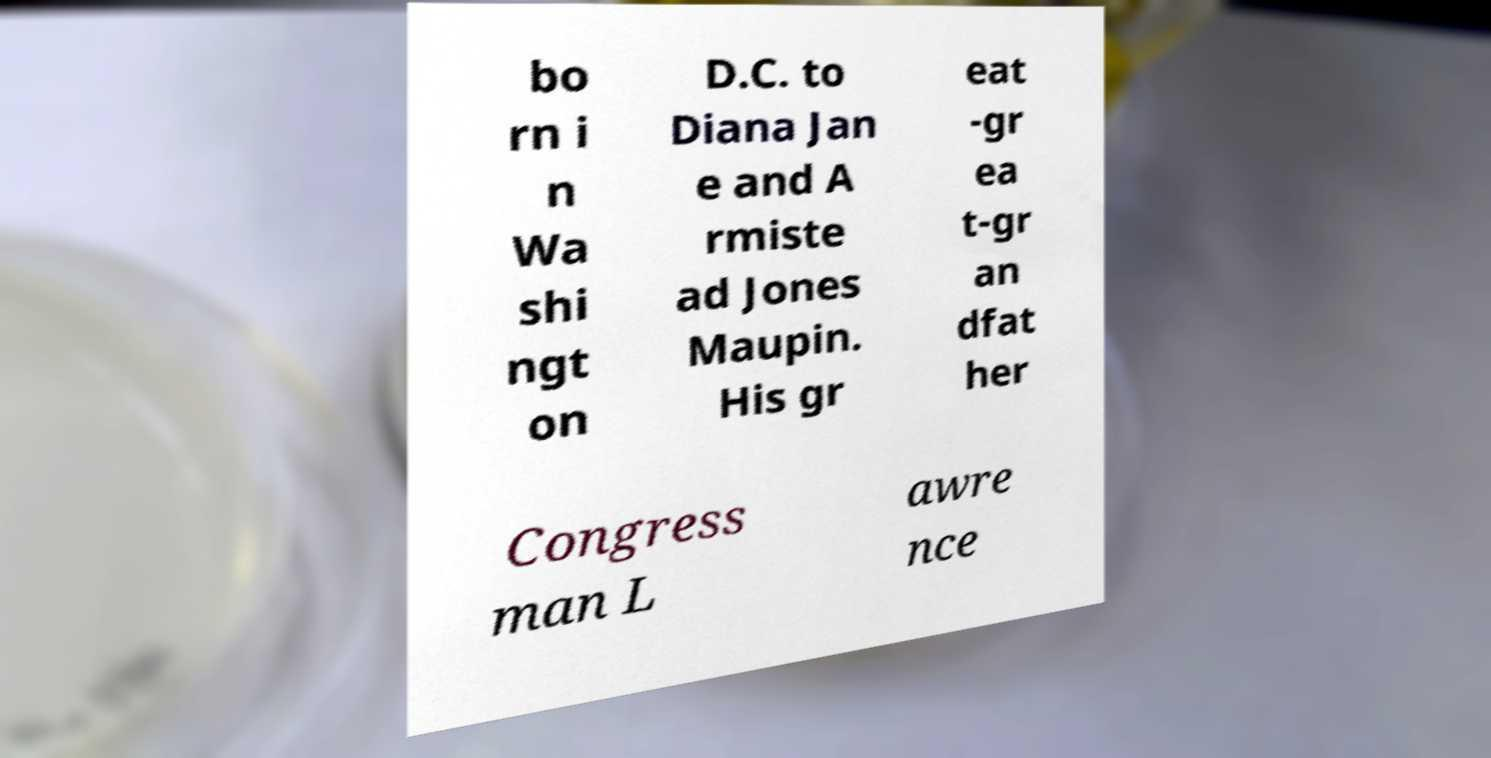Please read and relay the text visible in this image. What does it say? bo rn i n Wa shi ngt on D.C. to Diana Jan e and A rmiste ad Jones Maupin. His gr eat -gr ea t-gr an dfat her Congress man L awre nce 